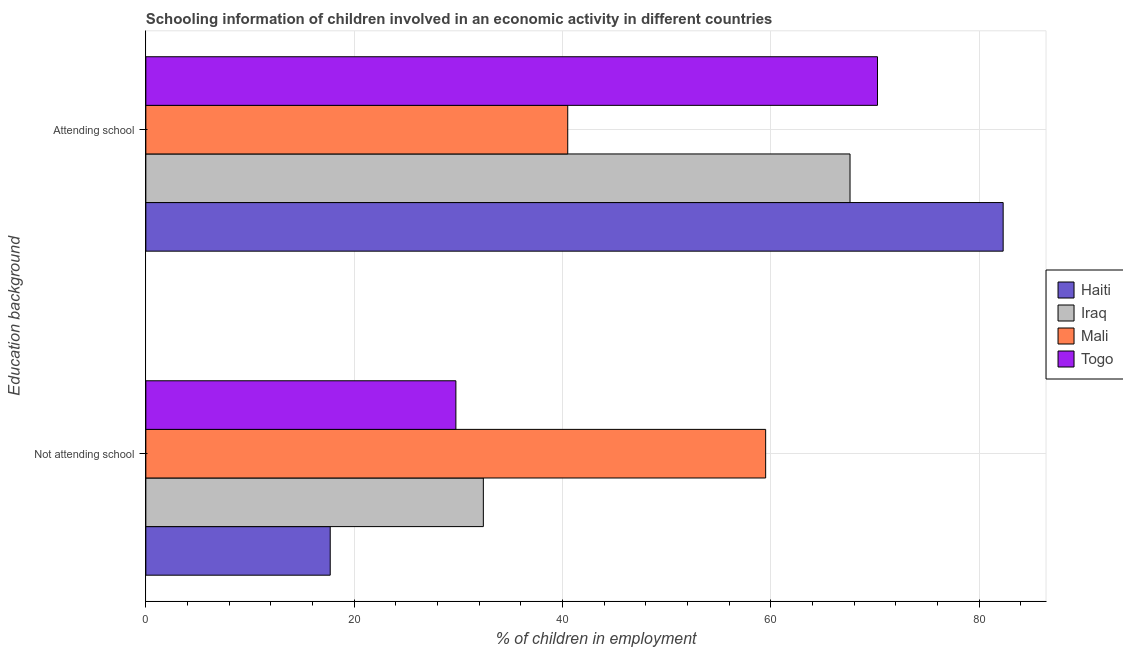How many different coloured bars are there?
Your answer should be compact. 4. Are the number of bars per tick equal to the number of legend labels?
Provide a succinct answer. Yes. How many bars are there on the 2nd tick from the top?
Your answer should be very brief. 4. What is the label of the 1st group of bars from the top?
Your answer should be compact. Attending school. What is the percentage of employed children who are not attending school in Mali?
Provide a short and direct response. 59.5. Across all countries, what is the maximum percentage of employed children who are attending school?
Your response must be concise. 82.3. Across all countries, what is the minimum percentage of employed children who are attending school?
Keep it short and to the point. 40.5. In which country was the percentage of employed children who are attending school maximum?
Provide a short and direct response. Haiti. In which country was the percentage of employed children who are not attending school minimum?
Provide a short and direct response. Haiti. What is the total percentage of employed children who are not attending school in the graph?
Your answer should be compact. 139.36. What is the difference between the percentage of employed children who are not attending school in Haiti and that in Togo?
Your answer should be compact. -12.06. What is the difference between the percentage of employed children who are attending school in Mali and the percentage of employed children who are not attending school in Togo?
Make the answer very short. 10.74. What is the average percentage of employed children who are not attending school per country?
Your answer should be very brief. 34.84. What is the difference between the percentage of employed children who are attending school and percentage of employed children who are not attending school in Haiti?
Keep it short and to the point. 64.6. What is the ratio of the percentage of employed children who are not attending school in Haiti to that in Togo?
Keep it short and to the point. 0.59. Is the percentage of employed children who are attending school in Iraq less than that in Togo?
Your answer should be compact. Yes. What does the 1st bar from the top in Attending school represents?
Offer a terse response. Togo. What does the 4th bar from the bottom in Not attending school represents?
Your answer should be compact. Togo. How many bars are there?
Provide a succinct answer. 8. Are all the bars in the graph horizontal?
Your answer should be compact. Yes. What is the difference between two consecutive major ticks on the X-axis?
Provide a short and direct response. 20. Are the values on the major ticks of X-axis written in scientific E-notation?
Your answer should be very brief. No. Does the graph contain any zero values?
Provide a short and direct response. No. Where does the legend appear in the graph?
Your answer should be compact. Center right. How are the legend labels stacked?
Provide a succinct answer. Vertical. What is the title of the graph?
Ensure brevity in your answer.  Schooling information of children involved in an economic activity in different countries. Does "Senegal" appear as one of the legend labels in the graph?
Offer a terse response. No. What is the label or title of the X-axis?
Offer a very short reply. % of children in employment. What is the label or title of the Y-axis?
Offer a terse response. Education background. What is the % of children in employment in Iraq in Not attending school?
Offer a terse response. 32.4. What is the % of children in employment in Mali in Not attending school?
Give a very brief answer. 59.5. What is the % of children in employment of Togo in Not attending school?
Make the answer very short. 29.76. What is the % of children in employment in Haiti in Attending school?
Offer a very short reply. 82.3. What is the % of children in employment in Iraq in Attending school?
Ensure brevity in your answer.  67.6. What is the % of children in employment in Mali in Attending school?
Your response must be concise. 40.5. What is the % of children in employment in Togo in Attending school?
Offer a very short reply. 70.24. Across all Education background, what is the maximum % of children in employment of Haiti?
Keep it short and to the point. 82.3. Across all Education background, what is the maximum % of children in employment of Iraq?
Ensure brevity in your answer.  67.6. Across all Education background, what is the maximum % of children in employment in Mali?
Your answer should be very brief. 59.5. Across all Education background, what is the maximum % of children in employment of Togo?
Keep it short and to the point. 70.24. Across all Education background, what is the minimum % of children in employment of Iraq?
Keep it short and to the point. 32.4. Across all Education background, what is the minimum % of children in employment in Mali?
Offer a terse response. 40.5. Across all Education background, what is the minimum % of children in employment in Togo?
Your answer should be very brief. 29.76. What is the total % of children in employment in Togo in the graph?
Offer a very short reply. 100. What is the difference between the % of children in employment in Haiti in Not attending school and that in Attending school?
Offer a terse response. -64.6. What is the difference between the % of children in employment in Iraq in Not attending school and that in Attending school?
Your answer should be compact. -35.2. What is the difference between the % of children in employment in Mali in Not attending school and that in Attending school?
Give a very brief answer. 19. What is the difference between the % of children in employment of Togo in Not attending school and that in Attending school?
Provide a succinct answer. -40.47. What is the difference between the % of children in employment of Haiti in Not attending school and the % of children in employment of Iraq in Attending school?
Offer a terse response. -49.9. What is the difference between the % of children in employment of Haiti in Not attending school and the % of children in employment of Mali in Attending school?
Your answer should be very brief. -22.8. What is the difference between the % of children in employment of Haiti in Not attending school and the % of children in employment of Togo in Attending school?
Provide a short and direct response. -52.54. What is the difference between the % of children in employment of Iraq in Not attending school and the % of children in employment of Togo in Attending school?
Make the answer very short. -37.84. What is the difference between the % of children in employment in Mali in Not attending school and the % of children in employment in Togo in Attending school?
Your answer should be compact. -10.74. What is the average % of children in employment of Haiti per Education background?
Your response must be concise. 50. What is the average % of children in employment in Togo per Education background?
Your answer should be very brief. 50. What is the difference between the % of children in employment of Haiti and % of children in employment of Iraq in Not attending school?
Provide a succinct answer. -14.7. What is the difference between the % of children in employment in Haiti and % of children in employment in Mali in Not attending school?
Provide a succinct answer. -41.8. What is the difference between the % of children in employment in Haiti and % of children in employment in Togo in Not attending school?
Your response must be concise. -12.06. What is the difference between the % of children in employment of Iraq and % of children in employment of Mali in Not attending school?
Make the answer very short. -27.1. What is the difference between the % of children in employment in Iraq and % of children in employment in Togo in Not attending school?
Give a very brief answer. 2.64. What is the difference between the % of children in employment in Mali and % of children in employment in Togo in Not attending school?
Keep it short and to the point. 29.74. What is the difference between the % of children in employment in Haiti and % of children in employment in Iraq in Attending school?
Provide a succinct answer. 14.7. What is the difference between the % of children in employment of Haiti and % of children in employment of Mali in Attending school?
Offer a very short reply. 41.8. What is the difference between the % of children in employment of Haiti and % of children in employment of Togo in Attending school?
Provide a short and direct response. 12.06. What is the difference between the % of children in employment of Iraq and % of children in employment of Mali in Attending school?
Your answer should be very brief. 27.1. What is the difference between the % of children in employment of Iraq and % of children in employment of Togo in Attending school?
Provide a short and direct response. -2.64. What is the difference between the % of children in employment of Mali and % of children in employment of Togo in Attending school?
Provide a short and direct response. -29.74. What is the ratio of the % of children in employment of Haiti in Not attending school to that in Attending school?
Your answer should be compact. 0.22. What is the ratio of the % of children in employment in Iraq in Not attending school to that in Attending school?
Your answer should be compact. 0.48. What is the ratio of the % of children in employment in Mali in Not attending school to that in Attending school?
Offer a very short reply. 1.47. What is the ratio of the % of children in employment of Togo in Not attending school to that in Attending school?
Your answer should be very brief. 0.42. What is the difference between the highest and the second highest % of children in employment in Haiti?
Keep it short and to the point. 64.6. What is the difference between the highest and the second highest % of children in employment of Iraq?
Keep it short and to the point. 35.2. What is the difference between the highest and the second highest % of children in employment of Togo?
Your answer should be very brief. 40.47. What is the difference between the highest and the lowest % of children in employment in Haiti?
Offer a terse response. 64.6. What is the difference between the highest and the lowest % of children in employment in Iraq?
Your answer should be compact. 35.2. What is the difference between the highest and the lowest % of children in employment in Togo?
Your response must be concise. 40.47. 